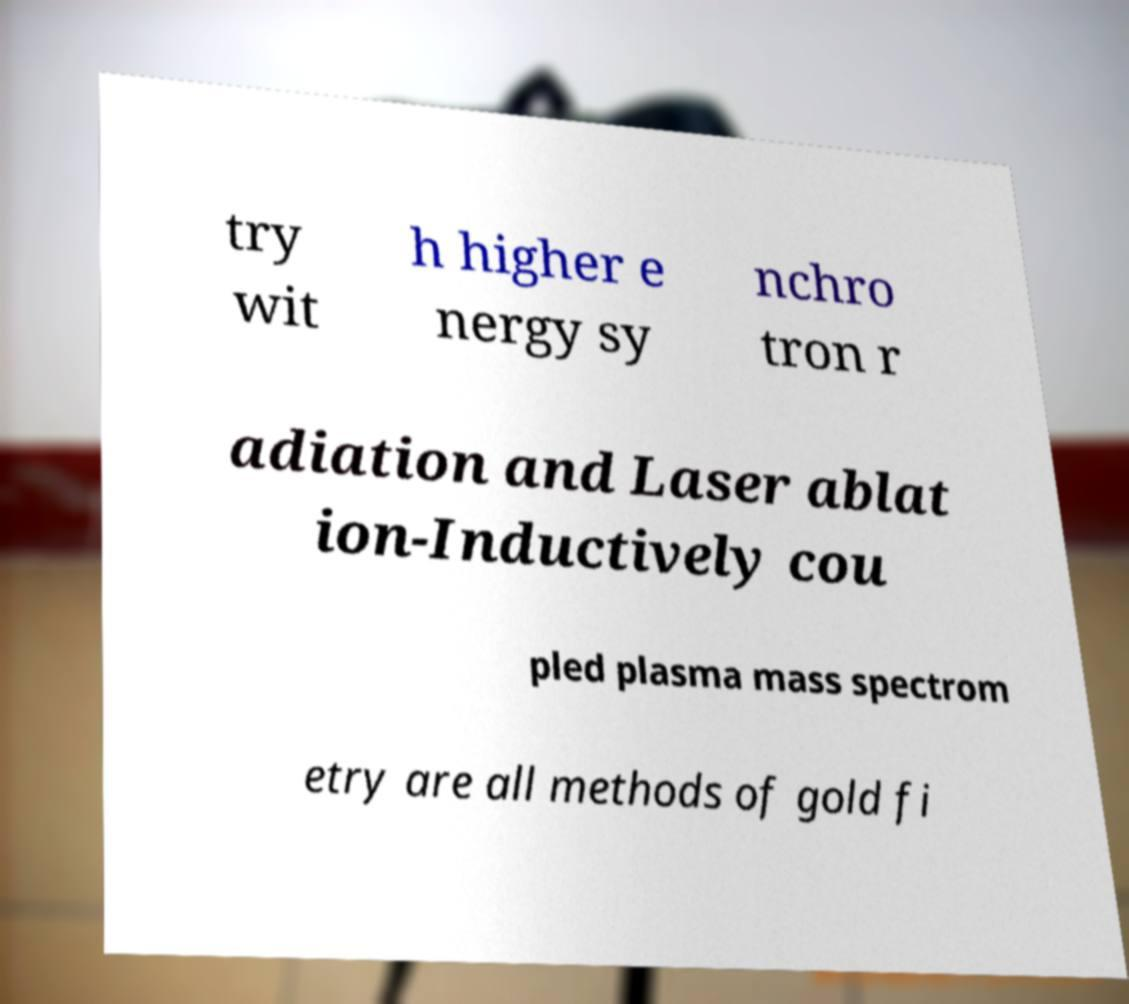What messages or text are displayed in this image? I need them in a readable, typed format. try wit h higher e nergy sy nchro tron r adiation and Laser ablat ion-Inductively cou pled plasma mass spectrom etry are all methods of gold fi 